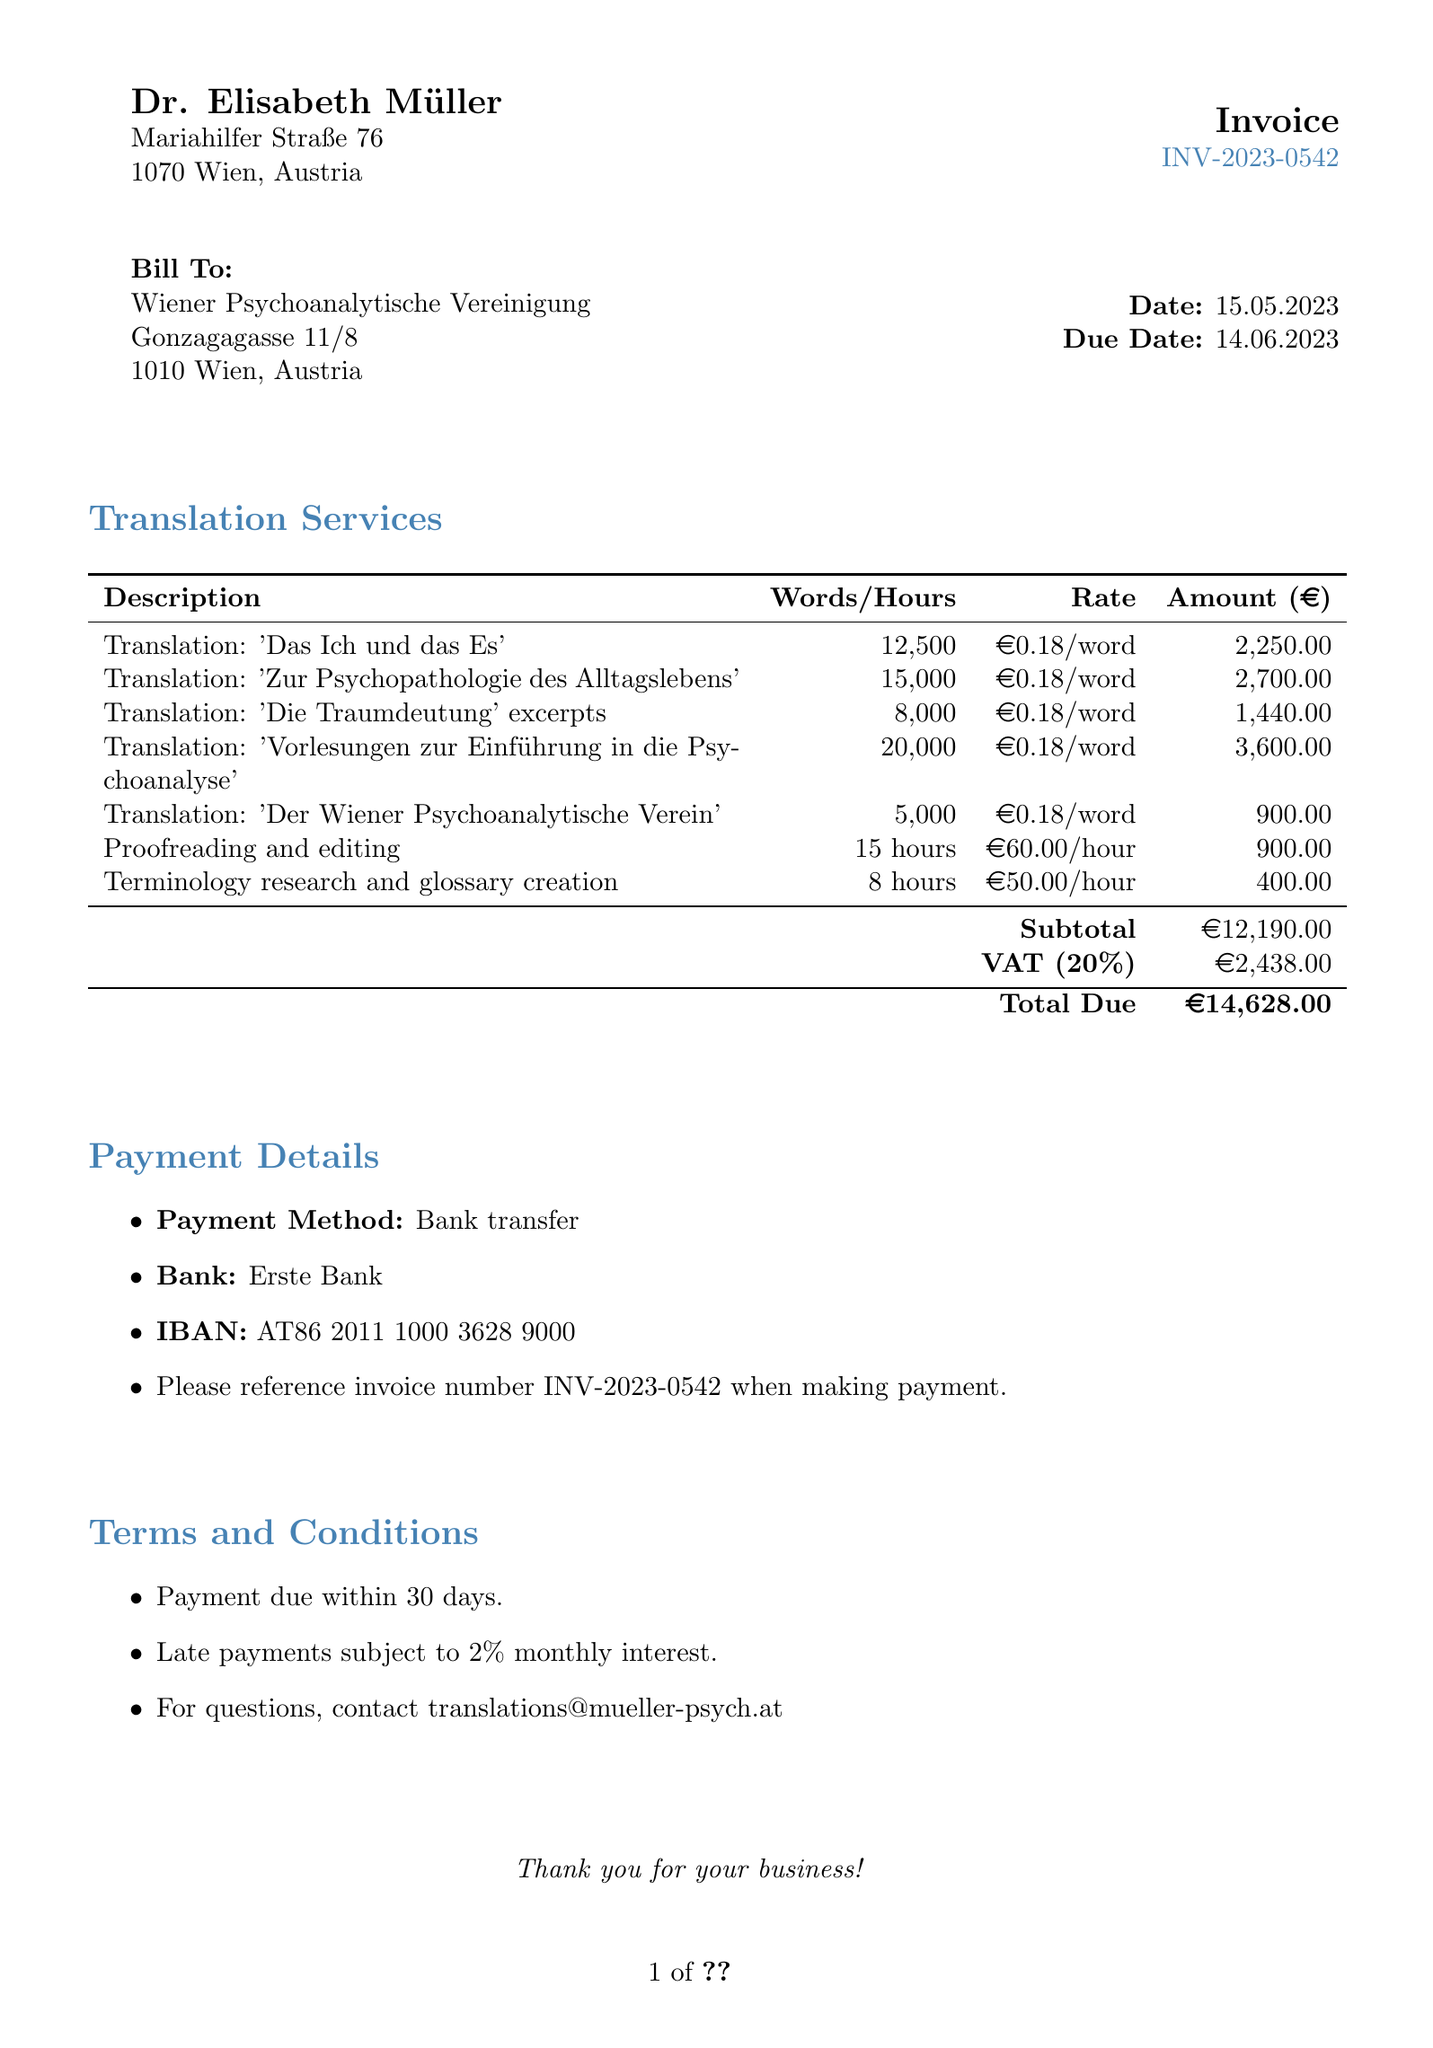What is the invoice number? The invoice number is clearly stated at the top of the document as INV-2023-0542.
Answer: INV-2023-0542 Who is the translator? The translator is mentioned in the header of the document as Dr. Elisabeth Müller.
Answer: Dr. Elisabeth Müller What is the due date for payment? The due date is specified next to the date in the document, which is 14.06.2023.
Answer: 14.06.2023 What is the total amount due? The total amount due is provided at the bottom of the invoice as the total due amount, which is €14,628.00.
Answer: €14,628.00 How many hours were allocated for proofreading and editing? The document lists the hours for proofreading and editing as 15 hours in the line items section.
Answer: 15 hours What is the VAT rate applied? The VAT rate is mentioned in the totals section as 20%.
Answer: 20% How much was charged for terminology research and glossary creation? The amount charged for terminology research and glossary creation is stated in the amount column as €400.00.
Answer: €400.00 What payment method is specified in the document? The payment method is listed in the payment details section as bank transfer.
Answer: Bank transfer 